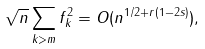Convert formula to latex. <formula><loc_0><loc_0><loc_500><loc_500>\sqrt { n } \sum _ { k > m } f _ { k } ^ { 2 } = O ( n ^ { 1 / 2 + r ( 1 - 2 s ) } ) ,</formula> 